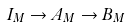Convert formula to latex. <formula><loc_0><loc_0><loc_500><loc_500>I _ { M } \rightarrow A _ { M } \rightarrow B _ { M }</formula> 